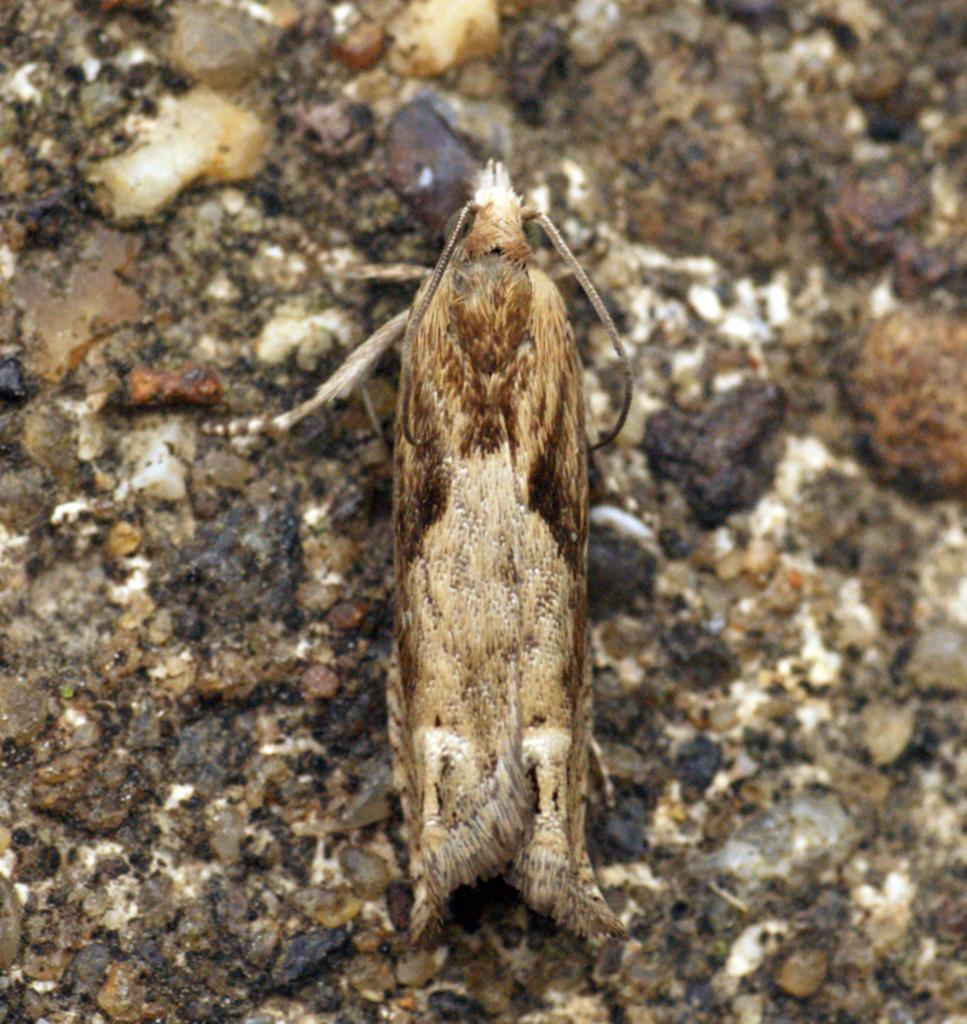What type of creature can be seen in the image? There is an insect in the image. Where is the insect located in the image? The insect is on the ground. Is the insect using its knee to climb the wall in the image? There is no wall present in the image, and insects do not have knees like humans. 